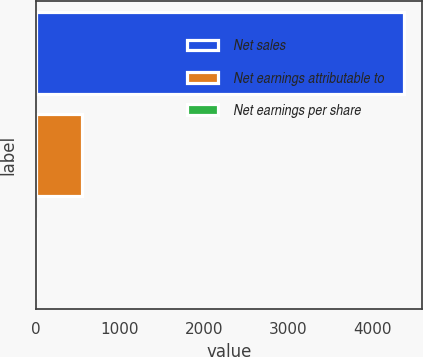Convert chart to OTSL. <chart><loc_0><loc_0><loc_500><loc_500><bar_chart><fcel>Net sales<fcel>Net earnings attributable to<fcel>Net earnings per share<nl><fcel>4373.9<fcel>553.9<fcel>7.71<nl></chart> 